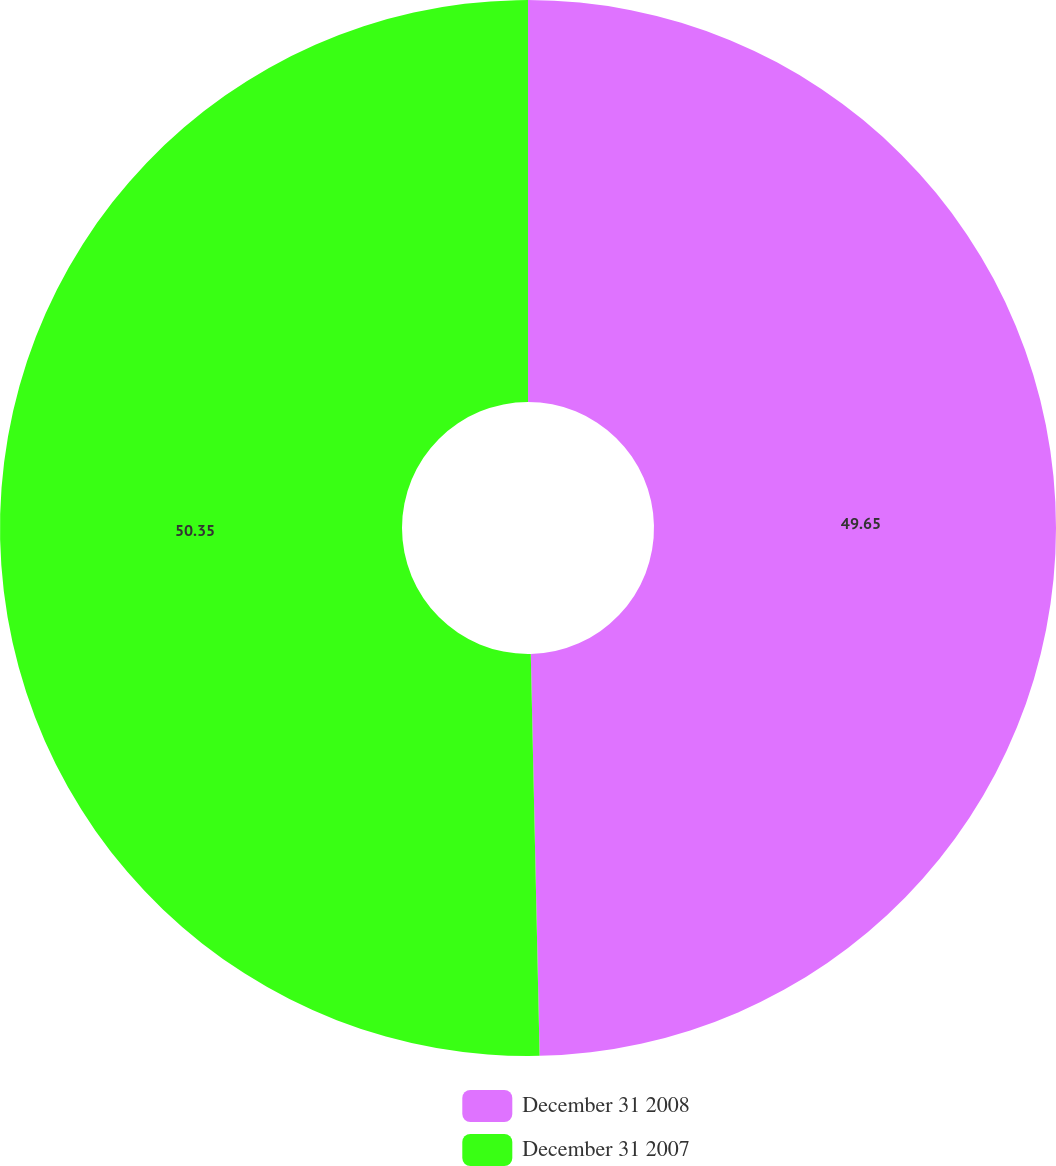<chart> <loc_0><loc_0><loc_500><loc_500><pie_chart><fcel>December 31 2008<fcel>December 31 2007<nl><fcel>49.65%<fcel>50.35%<nl></chart> 